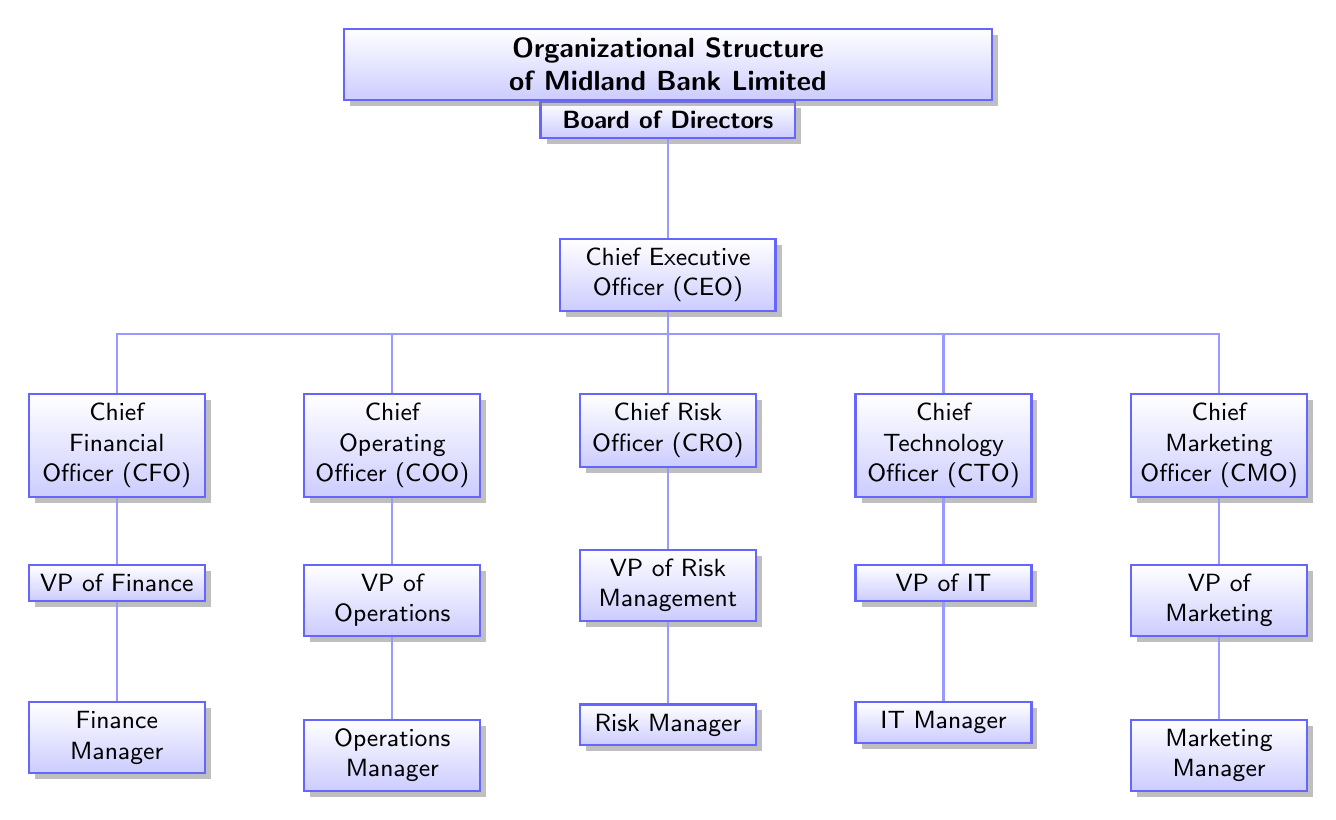What is the top-level node in the diagram? The top-level node represents the highest authority in the organizational structure, which is the "Board of Directors."
Answer: Board of Directors How many Chief Officers are listed in the diagram? By counting the nodes directly under the Board of Directors labeled as Chief Officers (CEO, CFO, COO, CRO, CTO, CMO), we find there are six.
Answer: 6 Who reports directly to the Chief Executive Officer? The node directly beneath the CEO is the Chief Financial Officer, with no other node between them.
Answer: Chief Financial Officer (CFO) Which department is managed by the Chief Technology Officer? The CTO oversees the "VP of IT," as indicated in the hierarchy directly underneath the CTO.
Answer: IT List the titles of the lowest-level management positions shown in the diagram. The lowest-level management positions include Finance Manager, Operations Manager, Risk Manager, IT Manager, and Marketing Manager.
Answer: Finance Manager, Operations Manager, Risk Manager, IT Manager, Marketing Manager In the organizational structure, which position is responsible for risk management? The position directly overseeing the risk management responsibilities is the Chief Risk Officer (CRO), as can be seen from their placement in the hierarchy.
Answer: Chief Risk Officer (CRO) How are the Chief Officers related to the Board of Directors? The Chief Officers are directly subordinate to the Board of Directors, indicated by the structured hierarchy showing a direct connection between them.
Answer: Directly subordinate What is the function of the VP in the context of the organizational structure shown? The Vice Presidents (VPs) serve as heads of their respective departments, reporting to the Chief Officers, indicating their managerial role in operations, finance, risk, technology, and marketing.
Answer: Department heads 